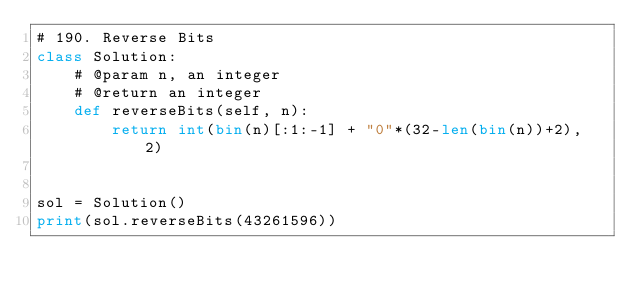<code> <loc_0><loc_0><loc_500><loc_500><_Python_># 190. Reverse Bits
class Solution:
    # @param n, an integer
    # @return an integer
    def reverseBits(self, n):
        return int(bin(n)[:1:-1] + "0"*(32-len(bin(n))+2), 2)


sol = Solution()
print(sol.reverseBits(43261596))</code> 